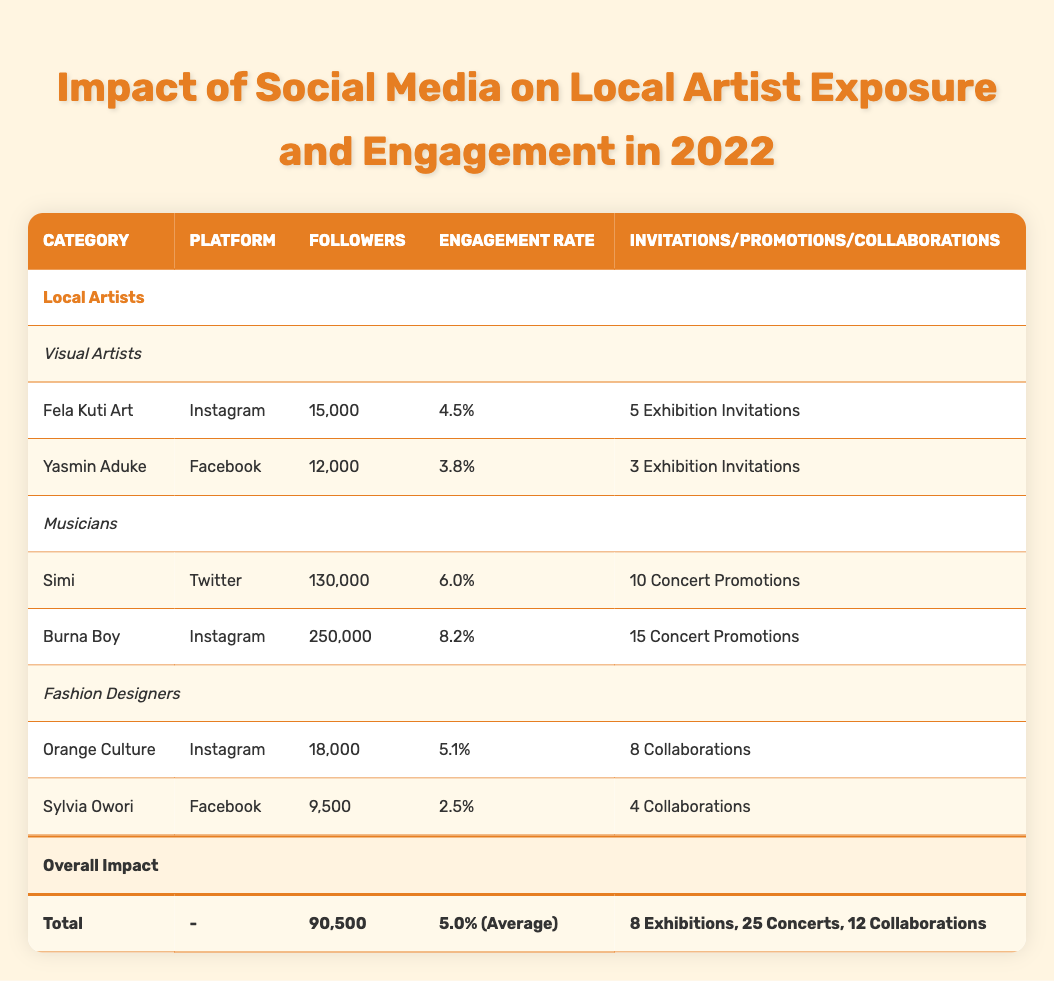What is the total number of followers for local artists? The table shows that the total number of followers for local artists is provided in the Overall Impact section. It states that the total followers is 90,500.
Answer: 90,500 Which artist has the highest engagement rate and what is that rate? By comparing the engagement rates listed for each artist, Burna Boy has the highest engagement rate at 8.2%.
Answer: 8.2% How many concert promotions does Simi have? The table lists Simi under Musicians and specifies that she has 10 concert promotions.
Answer: 10 What is the average engagement rate of all the local artists? The average engagement rate is provided in the Overall Impact section as 5.0%, indicating the overall performance of artist engagement across different categories.
Answer: 5.0% Did any visual artist receive more than 4 exhibition invitations? By checking the Exhibition Invitations for each visual artist, Fela Kuti Art has 5 invitations, which is more than 4. Therefore, the answer is yes.
Answer: Yes What is the total number of exhibition invitations and concert promotions combined? The table states there are 8 exhibition invitations and 25 concert promotions. Adding these together gives 8 + 25 = 33 total invitations and promotions.
Answer: 33 Which platform is used by the most followed musician? The musician with the highest number of followers is Burna Boy, who uses Instagram as his primary platform for engagement.
Answer: Instagram Is the engagement rate of Orange Culture higher than that of Sylvia Owori? Orange Culture has an engagement rate of 5.1%, while Sylvia Owori has an engagement rate of 2.5%. Since 5.1% is greater than 2.5%, the answer is yes.
Answer: Yes How many collaborations do all fashion designers have in total? The table lists Orange Culture with 8 collaborations and Sylvia Owori with 4 collaborations. Adding these gives a total of 8 + 4 = 12 collaborations among fashion designers.
Answer: 12 